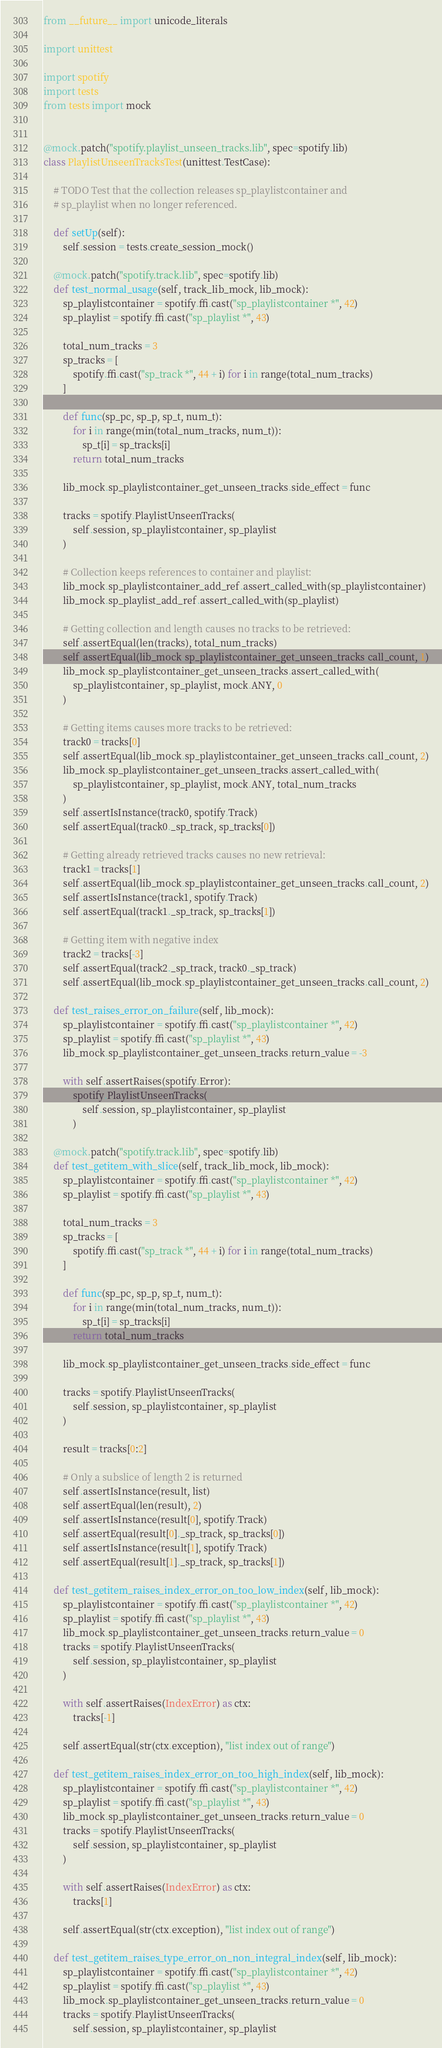<code> <loc_0><loc_0><loc_500><loc_500><_Python_>from __future__ import unicode_literals

import unittest

import spotify
import tests
from tests import mock


@mock.patch("spotify.playlist_unseen_tracks.lib", spec=spotify.lib)
class PlaylistUnseenTracksTest(unittest.TestCase):

    # TODO Test that the collection releases sp_playlistcontainer and
    # sp_playlist when no longer referenced.

    def setUp(self):
        self.session = tests.create_session_mock()

    @mock.patch("spotify.track.lib", spec=spotify.lib)
    def test_normal_usage(self, track_lib_mock, lib_mock):
        sp_playlistcontainer = spotify.ffi.cast("sp_playlistcontainer *", 42)
        sp_playlist = spotify.ffi.cast("sp_playlist *", 43)

        total_num_tracks = 3
        sp_tracks = [
            spotify.ffi.cast("sp_track *", 44 + i) for i in range(total_num_tracks)
        ]

        def func(sp_pc, sp_p, sp_t, num_t):
            for i in range(min(total_num_tracks, num_t)):
                sp_t[i] = sp_tracks[i]
            return total_num_tracks

        lib_mock.sp_playlistcontainer_get_unseen_tracks.side_effect = func

        tracks = spotify.PlaylistUnseenTracks(
            self.session, sp_playlistcontainer, sp_playlist
        )

        # Collection keeps references to container and playlist:
        lib_mock.sp_playlistcontainer_add_ref.assert_called_with(sp_playlistcontainer)
        lib_mock.sp_playlist_add_ref.assert_called_with(sp_playlist)

        # Getting collection and length causes no tracks to be retrieved:
        self.assertEqual(len(tracks), total_num_tracks)
        self.assertEqual(lib_mock.sp_playlistcontainer_get_unseen_tracks.call_count, 1)
        lib_mock.sp_playlistcontainer_get_unseen_tracks.assert_called_with(
            sp_playlistcontainer, sp_playlist, mock.ANY, 0
        )

        # Getting items causes more tracks to be retrieved:
        track0 = tracks[0]
        self.assertEqual(lib_mock.sp_playlistcontainer_get_unseen_tracks.call_count, 2)
        lib_mock.sp_playlistcontainer_get_unseen_tracks.assert_called_with(
            sp_playlistcontainer, sp_playlist, mock.ANY, total_num_tracks
        )
        self.assertIsInstance(track0, spotify.Track)
        self.assertEqual(track0._sp_track, sp_tracks[0])

        # Getting already retrieved tracks causes no new retrieval:
        track1 = tracks[1]
        self.assertEqual(lib_mock.sp_playlistcontainer_get_unseen_tracks.call_count, 2)
        self.assertIsInstance(track1, spotify.Track)
        self.assertEqual(track1._sp_track, sp_tracks[1])

        # Getting item with negative index
        track2 = tracks[-3]
        self.assertEqual(track2._sp_track, track0._sp_track)
        self.assertEqual(lib_mock.sp_playlistcontainer_get_unseen_tracks.call_count, 2)

    def test_raises_error_on_failure(self, lib_mock):
        sp_playlistcontainer = spotify.ffi.cast("sp_playlistcontainer *", 42)
        sp_playlist = spotify.ffi.cast("sp_playlist *", 43)
        lib_mock.sp_playlistcontainer_get_unseen_tracks.return_value = -3

        with self.assertRaises(spotify.Error):
            spotify.PlaylistUnseenTracks(
                self.session, sp_playlistcontainer, sp_playlist
            )

    @mock.patch("spotify.track.lib", spec=spotify.lib)
    def test_getitem_with_slice(self, track_lib_mock, lib_mock):
        sp_playlistcontainer = spotify.ffi.cast("sp_playlistcontainer *", 42)
        sp_playlist = spotify.ffi.cast("sp_playlist *", 43)

        total_num_tracks = 3
        sp_tracks = [
            spotify.ffi.cast("sp_track *", 44 + i) for i in range(total_num_tracks)
        ]

        def func(sp_pc, sp_p, sp_t, num_t):
            for i in range(min(total_num_tracks, num_t)):
                sp_t[i] = sp_tracks[i]
            return total_num_tracks

        lib_mock.sp_playlistcontainer_get_unseen_tracks.side_effect = func

        tracks = spotify.PlaylistUnseenTracks(
            self.session, sp_playlistcontainer, sp_playlist
        )

        result = tracks[0:2]

        # Only a subslice of length 2 is returned
        self.assertIsInstance(result, list)
        self.assertEqual(len(result), 2)
        self.assertIsInstance(result[0], spotify.Track)
        self.assertEqual(result[0]._sp_track, sp_tracks[0])
        self.assertIsInstance(result[1], spotify.Track)
        self.assertEqual(result[1]._sp_track, sp_tracks[1])

    def test_getitem_raises_index_error_on_too_low_index(self, lib_mock):
        sp_playlistcontainer = spotify.ffi.cast("sp_playlistcontainer *", 42)
        sp_playlist = spotify.ffi.cast("sp_playlist *", 43)
        lib_mock.sp_playlistcontainer_get_unseen_tracks.return_value = 0
        tracks = spotify.PlaylistUnseenTracks(
            self.session, sp_playlistcontainer, sp_playlist
        )

        with self.assertRaises(IndexError) as ctx:
            tracks[-1]

        self.assertEqual(str(ctx.exception), "list index out of range")

    def test_getitem_raises_index_error_on_too_high_index(self, lib_mock):
        sp_playlistcontainer = spotify.ffi.cast("sp_playlistcontainer *", 42)
        sp_playlist = spotify.ffi.cast("sp_playlist *", 43)
        lib_mock.sp_playlistcontainer_get_unseen_tracks.return_value = 0
        tracks = spotify.PlaylistUnseenTracks(
            self.session, sp_playlistcontainer, sp_playlist
        )

        with self.assertRaises(IndexError) as ctx:
            tracks[1]

        self.assertEqual(str(ctx.exception), "list index out of range")

    def test_getitem_raises_type_error_on_non_integral_index(self, lib_mock):
        sp_playlistcontainer = spotify.ffi.cast("sp_playlistcontainer *", 42)
        sp_playlist = spotify.ffi.cast("sp_playlist *", 43)
        lib_mock.sp_playlistcontainer_get_unseen_tracks.return_value = 0
        tracks = spotify.PlaylistUnseenTracks(
            self.session, sp_playlistcontainer, sp_playlist</code> 